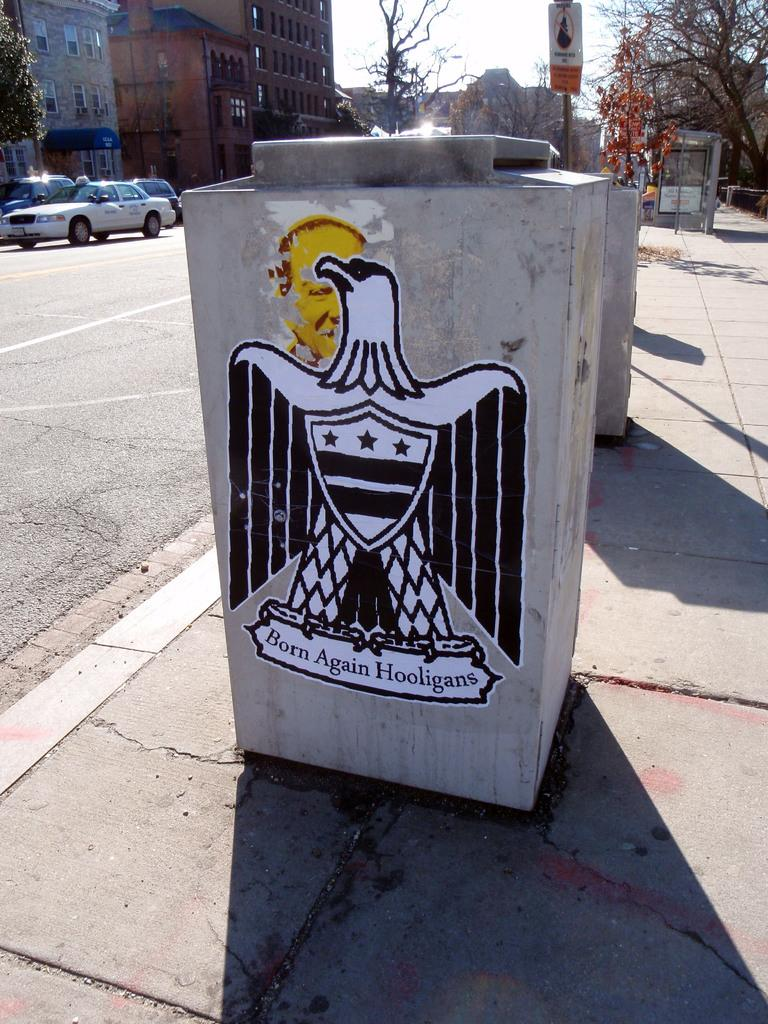<image>
Create a compact narrative representing the image presented. Giant stone with a picture of an eagle and the words" Born Again Hooligans". 